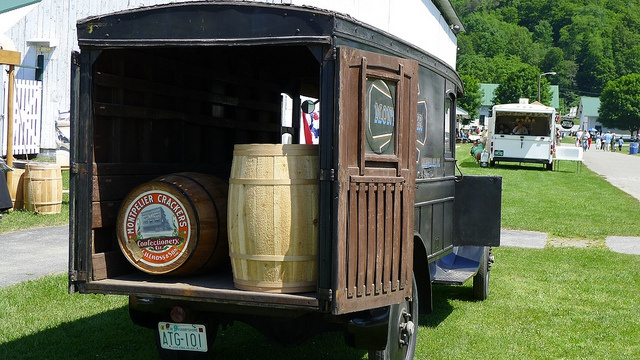Describe the objects in this image and their specific colors. I can see truck in lightblue, black, gray, and darkgray tones, truck in lightblue, black, white, and darkgray tones, people in lightblue, turquoise, black, teal, and gray tones, people in lightblue, black, gray, maroon, and purple tones, and people in lightblue, lightgray, darkgray, and gray tones in this image. 